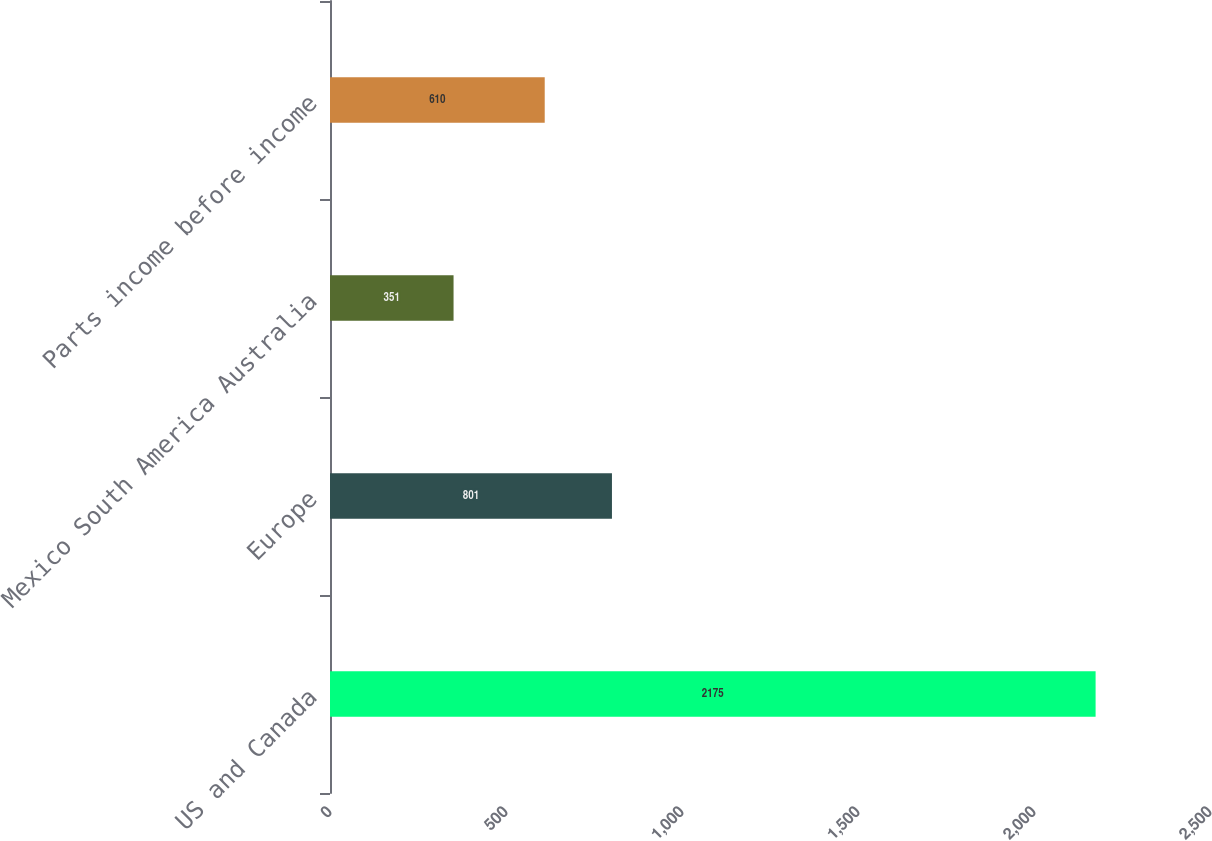<chart> <loc_0><loc_0><loc_500><loc_500><bar_chart><fcel>US and Canada<fcel>Europe<fcel>Mexico South America Australia<fcel>Parts income before income<nl><fcel>2175<fcel>801<fcel>351<fcel>610<nl></chart> 